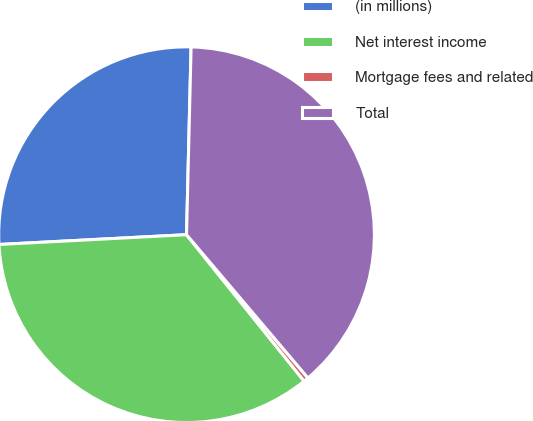<chart> <loc_0><loc_0><loc_500><loc_500><pie_chart><fcel>(in millions)<fcel>Net interest income<fcel>Mortgage fees and related<fcel>Total<nl><fcel>26.22%<fcel>34.94%<fcel>0.42%<fcel>38.43%<nl></chart> 